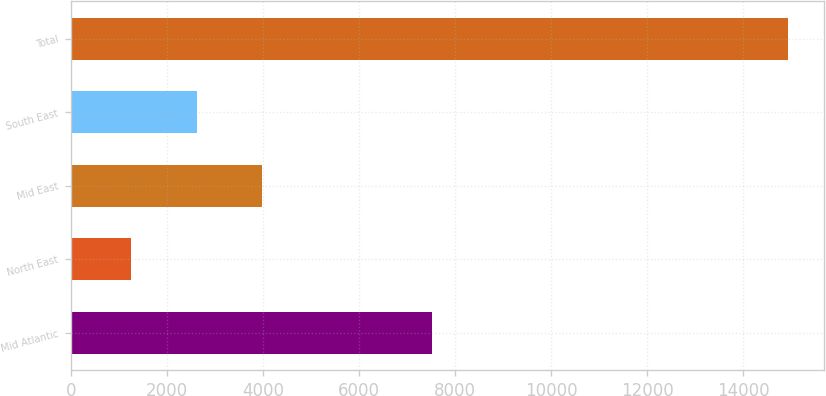Convert chart. <chart><loc_0><loc_0><loc_500><loc_500><bar_chart><fcel>Mid Atlantic<fcel>North East<fcel>Mid East<fcel>South East<fcel>Total<nl><fcel>7512<fcel>1246<fcel>3982.4<fcel>2614.2<fcel>14928<nl></chart> 